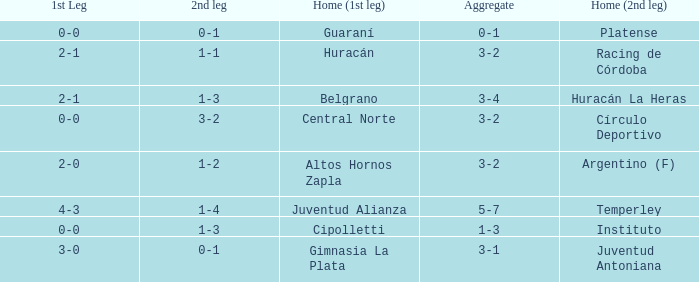Which team played the 2nd leg at home with a tie of 1-1 and scored 3-2 in aggregate? Racing de Córdoba. 